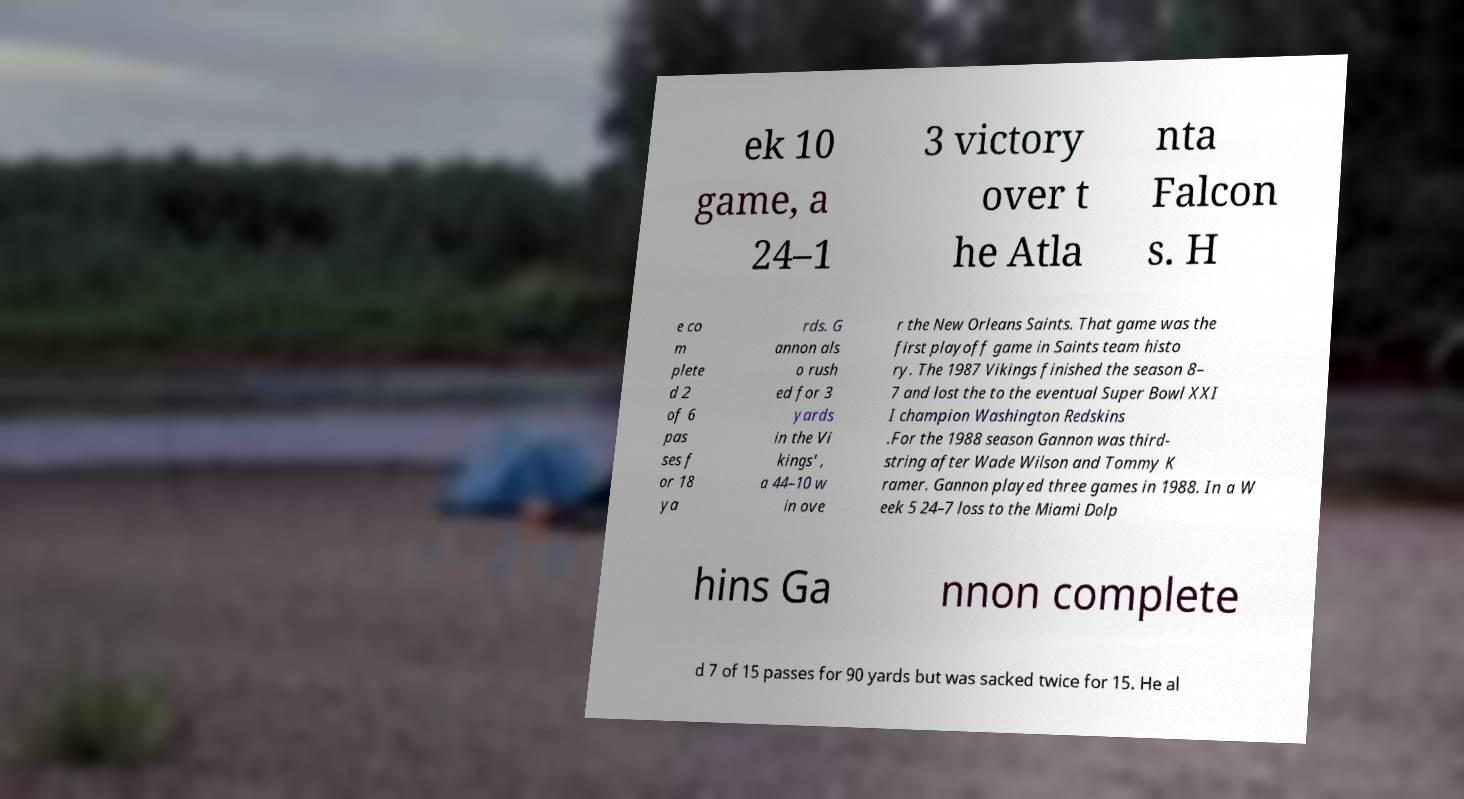Could you assist in decoding the text presented in this image and type it out clearly? ek 10 game, a 24–1 3 victory over t he Atla nta Falcon s. H e co m plete d 2 of 6 pas ses f or 18 ya rds. G annon als o rush ed for 3 yards in the Vi kings' , a 44–10 w in ove r the New Orleans Saints. That game was the first playoff game in Saints team histo ry. The 1987 Vikings finished the season 8– 7 and lost the to the eventual Super Bowl XXI I champion Washington Redskins .For the 1988 season Gannon was third- string after Wade Wilson and Tommy K ramer. Gannon played three games in 1988. In a W eek 5 24–7 loss to the Miami Dolp hins Ga nnon complete d 7 of 15 passes for 90 yards but was sacked twice for 15. He al 